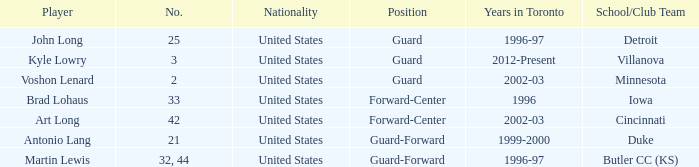Who is the player that wears number 42? Art Long. 